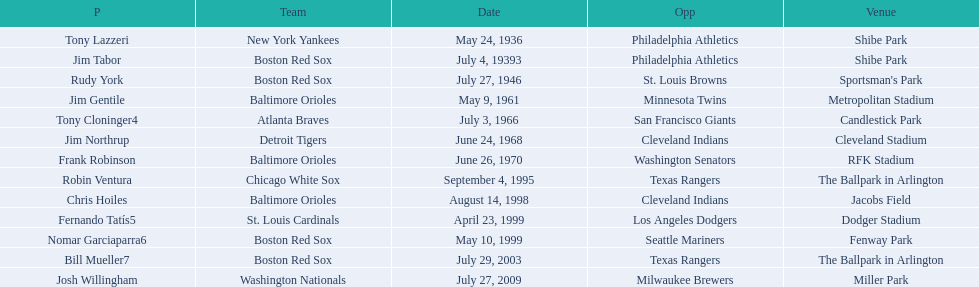Who are the opponents of the boston red sox during baseball home run records? Philadelphia Athletics, St. Louis Browns, Seattle Mariners, Texas Rangers. Of those which was the opponent on july 27, 1946? St. Louis Browns. 